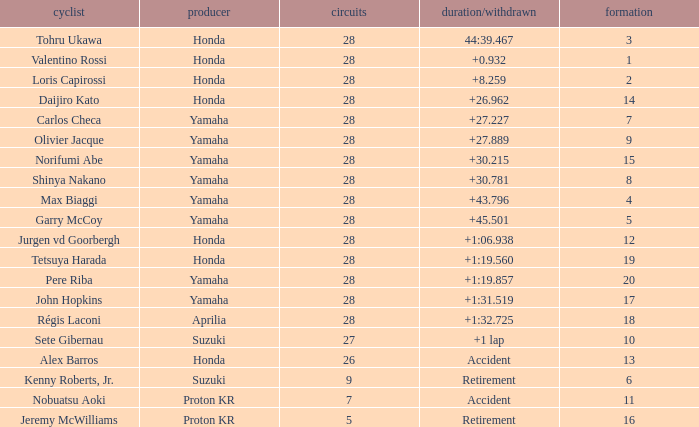How many laps were in grid 4? 28.0. 